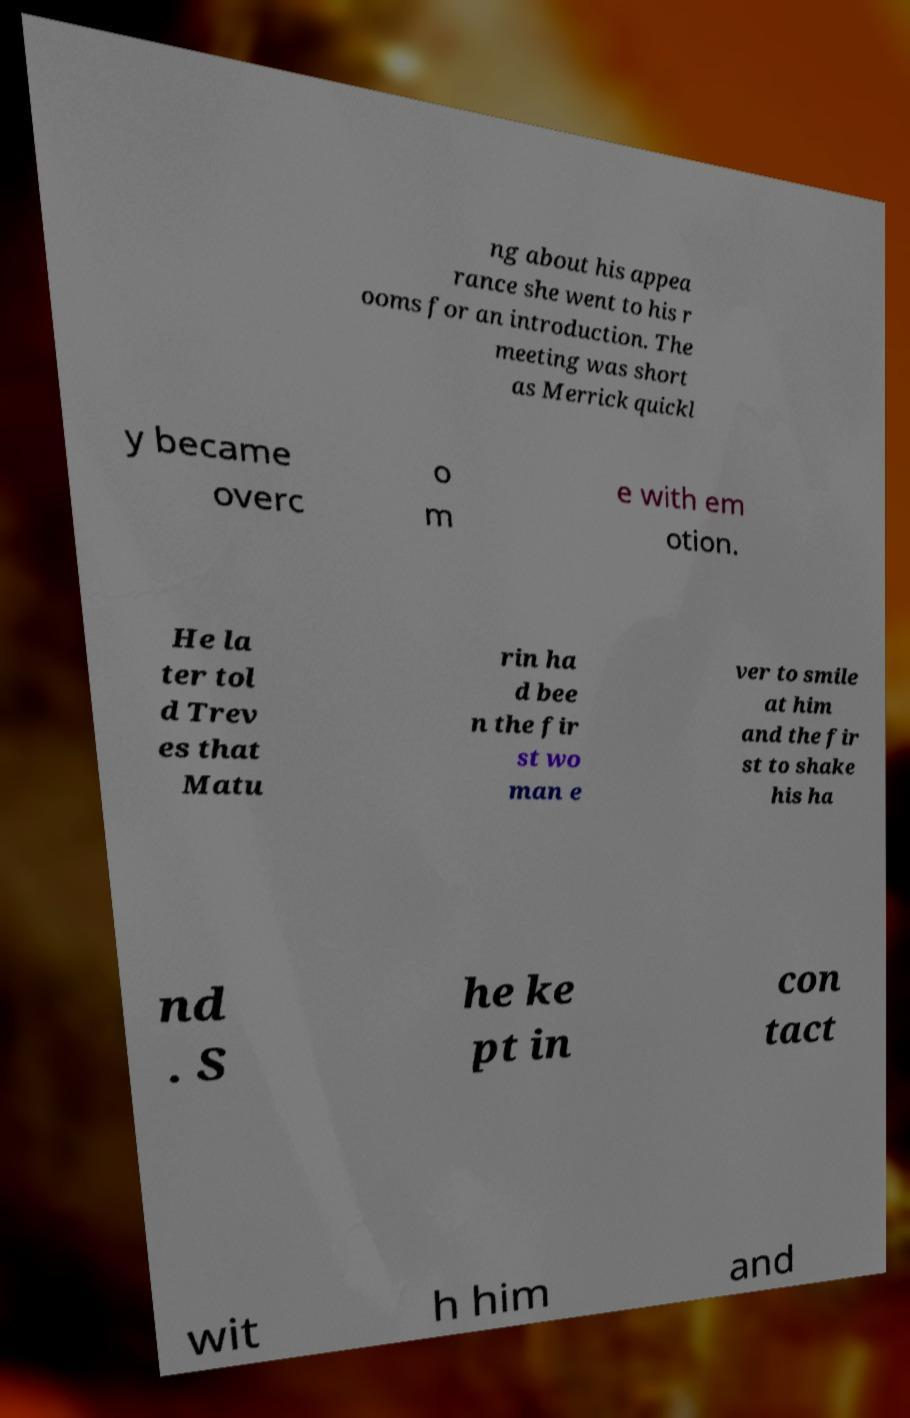There's text embedded in this image that I need extracted. Can you transcribe it verbatim? ng about his appea rance she went to his r ooms for an introduction. The meeting was short as Merrick quickl y became overc o m e with em otion. He la ter tol d Trev es that Matu rin ha d bee n the fir st wo man e ver to smile at him and the fir st to shake his ha nd . S he ke pt in con tact wit h him and 